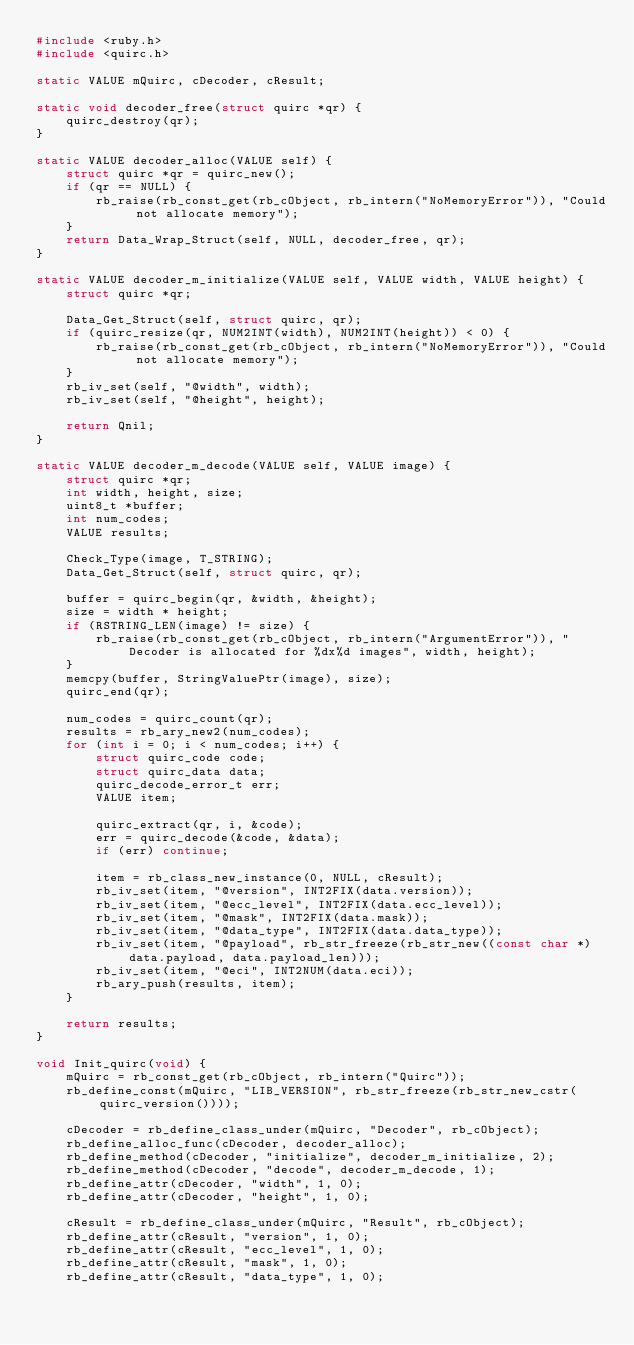<code> <loc_0><loc_0><loc_500><loc_500><_C_>#include <ruby.h>
#include <quirc.h>

static VALUE mQuirc, cDecoder, cResult;

static void decoder_free(struct quirc *qr) {
    quirc_destroy(qr);
}

static VALUE decoder_alloc(VALUE self) {
    struct quirc *qr = quirc_new();
    if (qr == NULL) {
        rb_raise(rb_const_get(rb_cObject, rb_intern("NoMemoryError")), "Could not allocate memory");
    }
    return Data_Wrap_Struct(self, NULL, decoder_free, qr);
}

static VALUE decoder_m_initialize(VALUE self, VALUE width, VALUE height) {
    struct quirc *qr;

    Data_Get_Struct(self, struct quirc, qr);
    if (quirc_resize(qr, NUM2INT(width), NUM2INT(height)) < 0) {
        rb_raise(rb_const_get(rb_cObject, rb_intern("NoMemoryError")), "Could not allocate memory");
    }
    rb_iv_set(self, "@width", width);
    rb_iv_set(self, "@height", height);

    return Qnil;
}

static VALUE decoder_m_decode(VALUE self, VALUE image) {
    struct quirc *qr;
    int width, height, size;
    uint8_t *buffer;
    int num_codes;
    VALUE results;

    Check_Type(image, T_STRING);
    Data_Get_Struct(self, struct quirc, qr);

    buffer = quirc_begin(qr, &width, &height);
    size = width * height;
    if (RSTRING_LEN(image) != size) {
        rb_raise(rb_const_get(rb_cObject, rb_intern("ArgumentError")), "Decoder is allocated for %dx%d images", width, height);
    }
    memcpy(buffer, StringValuePtr(image), size);
    quirc_end(qr);

    num_codes = quirc_count(qr);
    results = rb_ary_new2(num_codes);
    for (int i = 0; i < num_codes; i++) {
        struct quirc_code code;
        struct quirc_data data;
        quirc_decode_error_t err;
        VALUE item;

        quirc_extract(qr, i, &code);
        err = quirc_decode(&code, &data);
        if (err) continue;

        item = rb_class_new_instance(0, NULL, cResult);
        rb_iv_set(item, "@version", INT2FIX(data.version));
        rb_iv_set(item, "@ecc_level", INT2FIX(data.ecc_level));
        rb_iv_set(item, "@mask", INT2FIX(data.mask));
        rb_iv_set(item, "@data_type", INT2FIX(data.data_type));
        rb_iv_set(item, "@payload", rb_str_freeze(rb_str_new((const char *) data.payload, data.payload_len)));
        rb_iv_set(item, "@eci", INT2NUM(data.eci));
        rb_ary_push(results, item);
    }

    return results;
}

void Init_quirc(void) {
    mQuirc = rb_const_get(rb_cObject, rb_intern("Quirc"));
    rb_define_const(mQuirc, "LIB_VERSION", rb_str_freeze(rb_str_new_cstr(quirc_version())));

    cDecoder = rb_define_class_under(mQuirc, "Decoder", rb_cObject);
    rb_define_alloc_func(cDecoder, decoder_alloc);
    rb_define_method(cDecoder, "initialize", decoder_m_initialize, 2);
    rb_define_method(cDecoder, "decode", decoder_m_decode, 1);
    rb_define_attr(cDecoder, "width", 1, 0);
    rb_define_attr(cDecoder, "height", 1, 0);

    cResult = rb_define_class_under(mQuirc, "Result", rb_cObject);
    rb_define_attr(cResult, "version", 1, 0);
    rb_define_attr(cResult, "ecc_level", 1, 0);
    rb_define_attr(cResult, "mask", 1, 0);
    rb_define_attr(cResult, "data_type", 1, 0);</code> 